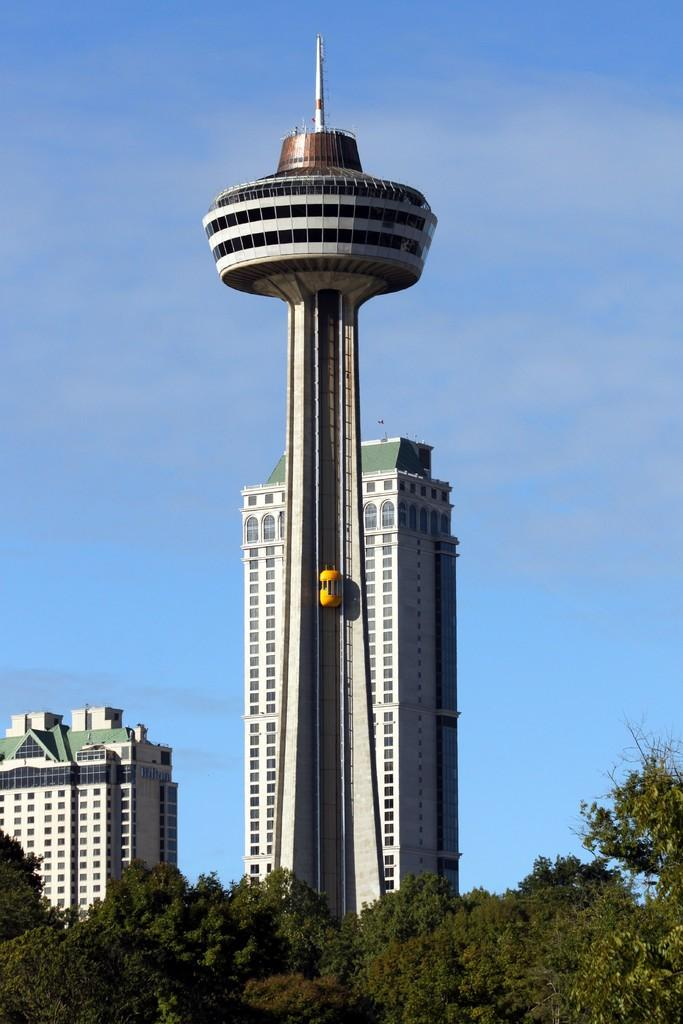What is located in the foreground of the picture? There are trees in the foreground of the picture. What structures can be seen in the center of the picture? There are buildings in the center of the picture. What is visible in the background of the image? The background of the image is the sky. Reasoning: Let's think step by step by following the provided facts step by step to produce the conversation. We start by identifying the main subjects and objects in the image based on the given facts. We then formulate questions that focus on the location and characteristics of these subjects and objects, ensuring that each question can be answered definitively with the information given. We avoid yes/no questions and ensure that the language is simple and clear. Absurd Question/Answer: Can you describe the family sitting on the ground in the image? There is no family or ground present in the image; it features trees in the foreground, buildings in the center, and the sky in the background. What type of detail can be seen on the family's clothing in the image? There is no family or clothing present in the image; it features trees in the foreground, buildings in the center, and the sky in the background. 